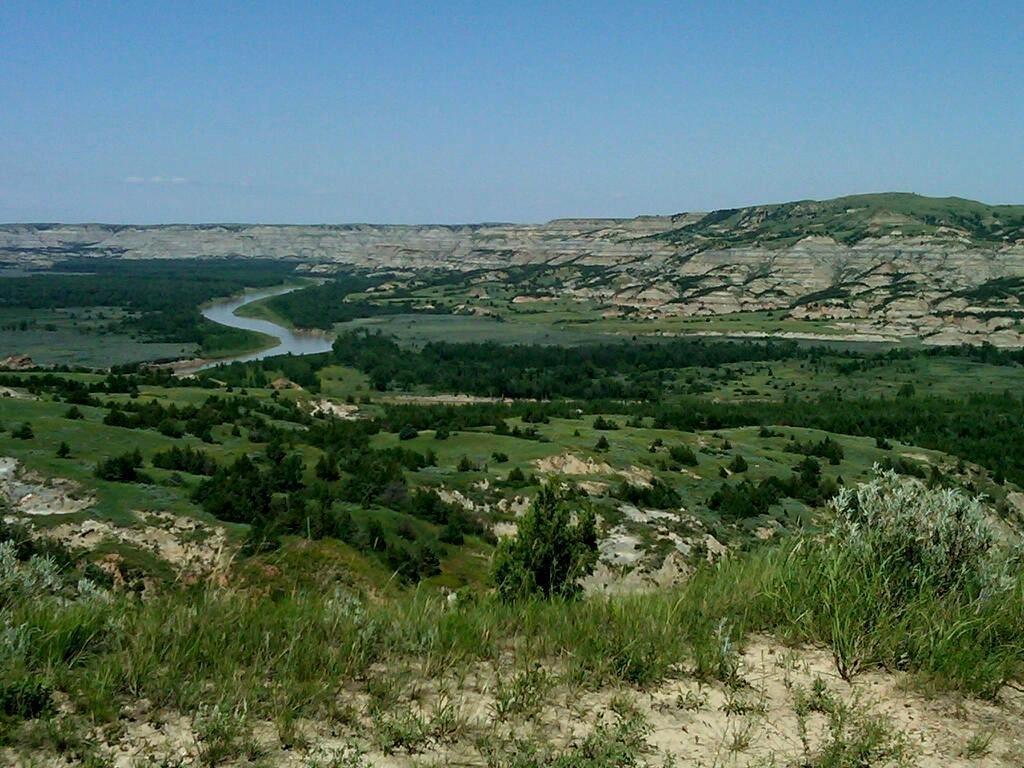Could you give a brief overview of what you see in this image? In the image we can see grass, trees, mountain, water and a sky. 